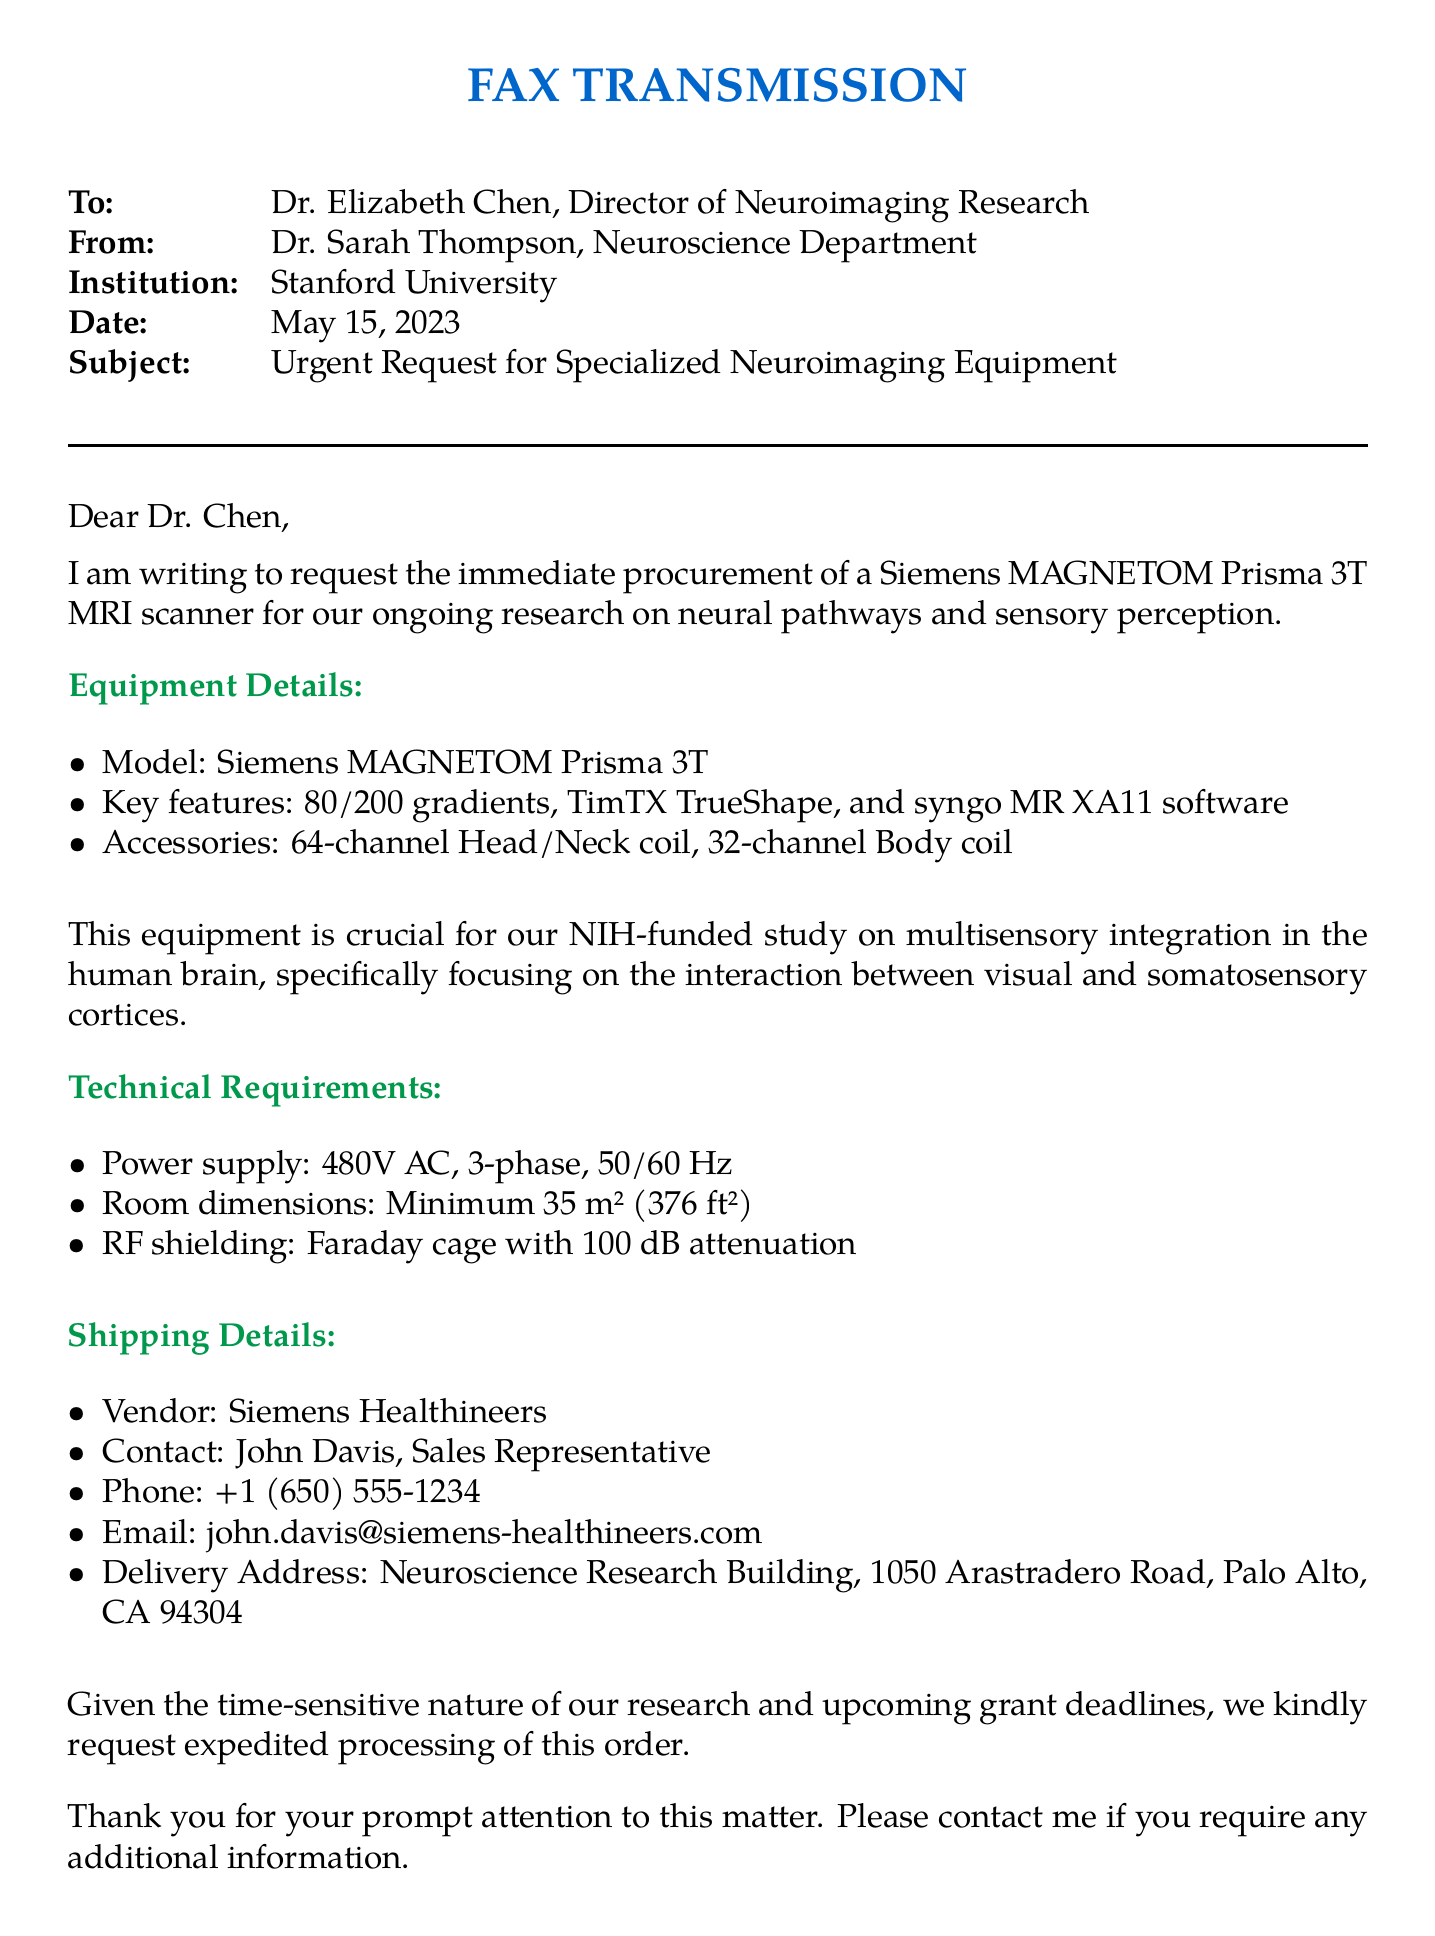What is the model of the requested equipment? The document states the model of the requested equipment as "Siemens MAGNETOM Prisma 3T".
Answer: Siemens MAGNETOM Prisma 3T Who is the Director of Neuroimaging Research? Dr. Elizabeth Chen is mentioned as the Director of Neuroimaging Research in the document.
Answer: Dr. Elizabeth Chen What is the power supply requirement? The document specifies the power supply requirement as "480V AC, 3-phase, 50/60 Hz".
Answer: 480V AC, 3-phase, 50/60 Hz What is the purpose of the requested equipment? The document describes the purpose as being crucial for a study on "multisensory integration in the human brain".
Answer: multisensory integration in the human brain What is the RF shielding requirement? The RF shielding requirement is stated in the document as "Faraday cage with 100 dB attenuation".
Answer: Faraday cage with 100 dB attenuation Who should be contacted for the procurement? John Davis, the Sales Representative from Siemens Healthineers, is to be contacted for procurement as mentioned in the document.
Answer: John Davis What is the delivery address for the equipment? The delivery address is listed in the document as "Neuroscience Research Building, 1050 Arastradero Road, Palo Alto, CA 94304".
Answer: Neuroscience Research Building, 1050 Arastradero Road, Palo Alto, CA 94304 What is the importance of expedited processing requested? The document mentions that expedited processing is requested due to "time-sensitive nature of our research and upcoming grant deadlines".
Answer: time-sensitive nature of our research and upcoming grant deadlines What type of coil is included in the accessories? The document lists the "64-channel Head/Neck coil" as one of the accessories.
Answer: 64-channel Head/Neck coil 